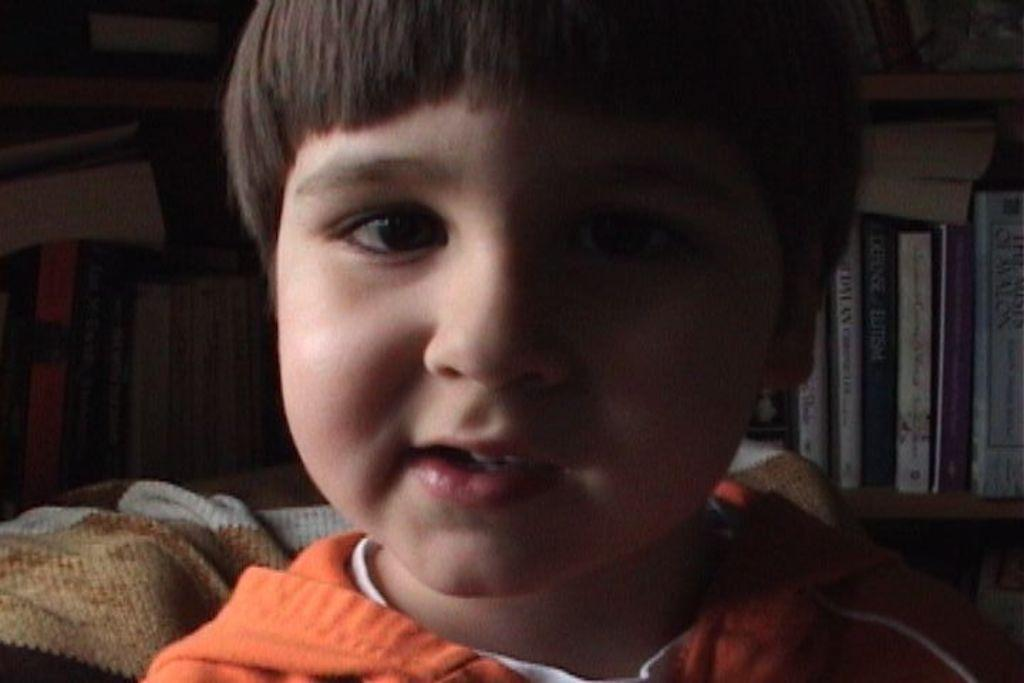What is the main subject of the image? The main subject of the image is a kid. Can you describe the background of the image? In the background of the image, there are books visible. What type of engine can be seen powering the roller coaster in the image? There is no roller coaster or engine present in the image; it features a kid and books in the background. 